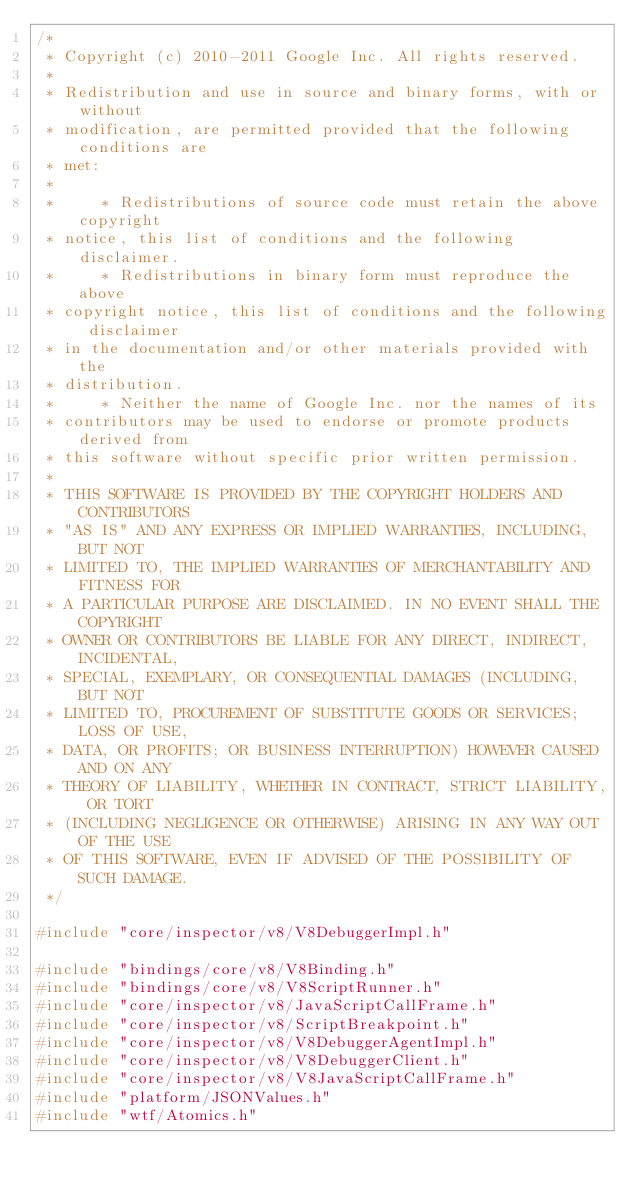Convert code to text. <code><loc_0><loc_0><loc_500><loc_500><_C++_>/*
 * Copyright (c) 2010-2011 Google Inc. All rights reserved.
 *
 * Redistribution and use in source and binary forms, with or without
 * modification, are permitted provided that the following conditions are
 * met:
 *
 *     * Redistributions of source code must retain the above copyright
 * notice, this list of conditions and the following disclaimer.
 *     * Redistributions in binary form must reproduce the above
 * copyright notice, this list of conditions and the following disclaimer
 * in the documentation and/or other materials provided with the
 * distribution.
 *     * Neither the name of Google Inc. nor the names of its
 * contributors may be used to endorse or promote products derived from
 * this software without specific prior written permission.
 *
 * THIS SOFTWARE IS PROVIDED BY THE COPYRIGHT HOLDERS AND CONTRIBUTORS
 * "AS IS" AND ANY EXPRESS OR IMPLIED WARRANTIES, INCLUDING, BUT NOT
 * LIMITED TO, THE IMPLIED WARRANTIES OF MERCHANTABILITY AND FITNESS FOR
 * A PARTICULAR PURPOSE ARE DISCLAIMED. IN NO EVENT SHALL THE COPYRIGHT
 * OWNER OR CONTRIBUTORS BE LIABLE FOR ANY DIRECT, INDIRECT, INCIDENTAL,
 * SPECIAL, EXEMPLARY, OR CONSEQUENTIAL DAMAGES (INCLUDING, BUT NOT
 * LIMITED TO, PROCUREMENT OF SUBSTITUTE GOODS OR SERVICES; LOSS OF USE,
 * DATA, OR PROFITS; OR BUSINESS INTERRUPTION) HOWEVER CAUSED AND ON ANY
 * THEORY OF LIABILITY, WHETHER IN CONTRACT, STRICT LIABILITY, OR TORT
 * (INCLUDING NEGLIGENCE OR OTHERWISE) ARISING IN ANY WAY OUT OF THE USE
 * OF THIS SOFTWARE, EVEN IF ADVISED OF THE POSSIBILITY OF SUCH DAMAGE.
 */

#include "core/inspector/v8/V8DebuggerImpl.h"

#include "bindings/core/v8/V8Binding.h"
#include "bindings/core/v8/V8ScriptRunner.h"
#include "core/inspector/v8/JavaScriptCallFrame.h"
#include "core/inspector/v8/ScriptBreakpoint.h"
#include "core/inspector/v8/V8DebuggerAgentImpl.h"
#include "core/inspector/v8/V8DebuggerClient.h"
#include "core/inspector/v8/V8JavaScriptCallFrame.h"
#include "platform/JSONValues.h"
#include "wtf/Atomics.h"</code> 